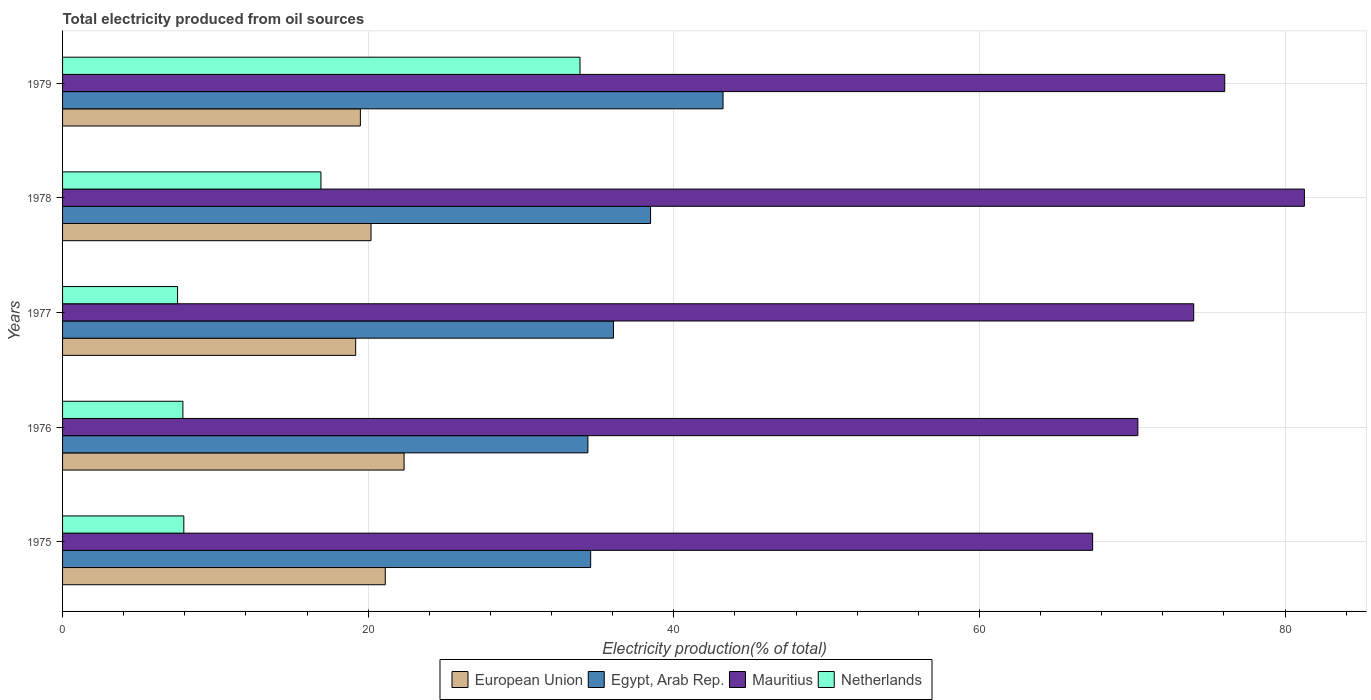How many different coloured bars are there?
Your answer should be compact. 4. How many groups of bars are there?
Keep it short and to the point. 5. Are the number of bars per tick equal to the number of legend labels?
Make the answer very short. Yes. Are the number of bars on each tick of the Y-axis equal?
Provide a succinct answer. Yes. How many bars are there on the 3rd tick from the top?
Offer a terse response. 4. How many bars are there on the 2nd tick from the bottom?
Provide a short and direct response. 4. What is the label of the 4th group of bars from the top?
Make the answer very short. 1976. In how many cases, is the number of bars for a given year not equal to the number of legend labels?
Offer a terse response. 0. What is the total electricity produced in European Union in 1976?
Ensure brevity in your answer.  22.35. Across all years, what is the maximum total electricity produced in European Union?
Provide a succinct answer. 22.35. Across all years, what is the minimum total electricity produced in European Union?
Offer a very short reply. 19.18. In which year was the total electricity produced in Netherlands maximum?
Provide a short and direct response. 1979. In which year was the total electricity produced in Egypt, Arab Rep. minimum?
Make the answer very short. 1976. What is the total total electricity produced in Egypt, Arab Rep. in the graph?
Your answer should be very brief. 186.7. What is the difference between the total electricity produced in Mauritius in 1977 and that in 1979?
Your answer should be very brief. -2.03. What is the difference between the total electricity produced in Netherlands in 1979 and the total electricity produced in European Union in 1978?
Ensure brevity in your answer.  13.68. What is the average total electricity produced in Mauritius per year?
Give a very brief answer. 73.83. In the year 1976, what is the difference between the total electricity produced in Netherlands and total electricity produced in Mauritius?
Offer a very short reply. -62.5. In how many years, is the total electricity produced in Egypt, Arab Rep. greater than 28 %?
Your response must be concise. 5. What is the ratio of the total electricity produced in Netherlands in 1977 to that in 1978?
Give a very brief answer. 0.45. Is the difference between the total electricity produced in Netherlands in 1977 and 1979 greater than the difference between the total electricity produced in Mauritius in 1977 and 1979?
Your answer should be very brief. No. What is the difference between the highest and the second highest total electricity produced in European Union?
Your answer should be very brief. 1.23. What is the difference between the highest and the lowest total electricity produced in European Union?
Keep it short and to the point. 3.17. In how many years, is the total electricity produced in Egypt, Arab Rep. greater than the average total electricity produced in Egypt, Arab Rep. taken over all years?
Offer a very short reply. 2. Is the sum of the total electricity produced in Egypt, Arab Rep. in 1976 and 1977 greater than the maximum total electricity produced in Netherlands across all years?
Make the answer very short. Yes. What does the 4th bar from the top in 1976 represents?
Provide a short and direct response. European Union. What does the 1st bar from the bottom in 1979 represents?
Your answer should be very brief. European Union. How many bars are there?
Make the answer very short. 20. How many years are there in the graph?
Ensure brevity in your answer.  5. Does the graph contain any zero values?
Give a very brief answer. No. Does the graph contain grids?
Offer a terse response. Yes. What is the title of the graph?
Keep it short and to the point. Total electricity produced from oil sources. What is the label or title of the X-axis?
Provide a short and direct response. Electricity production(% of total). What is the Electricity production(% of total) in European Union in 1975?
Offer a very short reply. 21.12. What is the Electricity production(% of total) in Egypt, Arab Rep. in 1975?
Your answer should be compact. 34.56. What is the Electricity production(% of total) in Mauritius in 1975?
Keep it short and to the point. 67.41. What is the Electricity production(% of total) of Netherlands in 1975?
Your answer should be very brief. 7.94. What is the Electricity production(% of total) of European Union in 1976?
Your answer should be compact. 22.35. What is the Electricity production(% of total) in Egypt, Arab Rep. in 1976?
Make the answer very short. 34.38. What is the Electricity production(% of total) in Mauritius in 1976?
Give a very brief answer. 70.37. What is the Electricity production(% of total) in Netherlands in 1976?
Offer a very short reply. 7.87. What is the Electricity production(% of total) of European Union in 1977?
Provide a succinct answer. 19.18. What is the Electricity production(% of total) in Egypt, Arab Rep. in 1977?
Make the answer very short. 36.05. What is the Electricity production(% of total) of Mauritius in 1977?
Ensure brevity in your answer.  74.03. What is the Electricity production(% of total) in Netherlands in 1977?
Your answer should be compact. 7.53. What is the Electricity production(% of total) of European Union in 1978?
Offer a very short reply. 20.19. What is the Electricity production(% of total) in Egypt, Arab Rep. in 1978?
Keep it short and to the point. 38.48. What is the Electricity production(% of total) in Mauritius in 1978?
Offer a terse response. 81.27. What is the Electricity production(% of total) of Netherlands in 1978?
Offer a very short reply. 16.91. What is the Electricity production(% of total) in European Union in 1979?
Offer a terse response. 19.49. What is the Electricity production(% of total) of Egypt, Arab Rep. in 1979?
Offer a very short reply. 43.22. What is the Electricity production(% of total) in Mauritius in 1979?
Make the answer very short. 76.06. What is the Electricity production(% of total) of Netherlands in 1979?
Give a very brief answer. 33.86. Across all years, what is the maximum Electricity production(% of total) of European Union?
Give a very brief answer. 22.35. Across all years, what is the maximum Electricity production(% of total) of Egypt, Arab Rep.?
Offer a very short reply. 43.22. Across all years, what is the maximum Electricity production(% of total) in Mauritius?
Offer a very short reply. 81.27. Across all years, what is the maximum Electricity production(% of total) in Netherlands?
Offer a very short reply. 33.86. Across all years, what is the minimum Electricity production(% of total) in European Union?
Offer a terse response. 19.18. Across all years, what is the minimum Electricity production(% of total) of Egypt, Arab Rep.?
Provide a short and direct response. 34.38. Across all years, what is the minimum Electricity production(% of total) in Mauritius?
Ensure brevity in your answer.  67.41. Across all years, what is the minimum Electricity production(% of total) of Netherlands?
Make the answer very short. 7.53. What is the total Electricity production(% of total) in European Union in the graph?
Keep it short and to the point. 102.33. What is the total Electricity production(% of total) in Egypt, Arab Rep. in the graph?
Offer a terse response. 186.7. What is the total Electricity production(% of total) in Mauritius in the graph?
Make the answer very short. 369.13. What is the total Electricity production(% of total) in Netherlands in the graph?
Make the answer very short. 74.11. What is the difference between the Electricity production(% of total) of European Union in 1975 and that in 1976?
Offer a terse response. -1.23. What is the difference between the Electricity production(% of total) of Egypt, Arab Rep. in 1975 and that in 1976?
Your answer should be very brief. 0.18. What is the difference between the Electricity production(% of total) of Mauritius in 1975 and that in 1976?
Your response must be concise. -2.96. What is the difference between the Electricity production(% of total) of Netherlands in 1975 and that in 1976?
Ensure brevity in your answer.  0.06. What is the difference between the Electricity production(% of total) in European Union in 1975 and that in 1977?
Provide a succinct answer. 1.94. What is the difference between the Electricity production(% of total) of Egypt, Arab Rep. in 1975 and that in 1977?
Your answer should be compact. -1.49. What is the difference between the Electricity production(% of total) in Mauritius in 1975 and that in 1977?
Give a very brief answer. -6.62. What is the difference between the Electricity production(% of total) of Netherlands in 1975 and that in 1977?
Your answer should be very brief. 0.41. What is the difference between the Electricity production(% of total) of European Union in 1975 and that in 1978?
Make the answer very short. 0.93. What is the difference between the Electricity production(% of total) of Egypt, Arab Rep. in 1975 and that in 1978?
Ensure brevity in your answer.  -3.92. What is the difference between the Electricity production(% of total) of Mauritius in 1975 and that in 1978?
Ensure brevity in your answer.  -13.86. What is the difference between the Electricity production(% of total) of Netherlands in 1975 and that in 1978?
Offer a very short reply. -8.97. What is the difference between the Electricity production(% of total) in European Union in 1975 and that in 1979?
Offer a very short reply. 1.63. What is the difference between the Electricity production(% of total) of Egypt, Arab Rep. in 1975 and that in 1979?
Provide a short and direct response. -8.66. What is the difference between the Electricity production(% of total) in Mauritius in 1975 and that in 1979?
Provide a short and direct response. -8.65. What is the difference between the Electricity production(% of total) in Netherlands in 1975 and that in 1979?
Provide a succinct answer. -25.93. What is the difference between the Electricity production(% of total) in European Union in 1976 and that in 1977?
Your response must be concise. 3.17. What is the difference between the Electricity production(% of total) of Egypt, Arab Rep. in 1976 and that in 1977?
Give a very brief answer. -1.67. What is the difference between the Electricity production(% of total) in Mauritius in 1976 and that in 1977?
Give a very brief answer. -3.66. What is the difference between the Electricity production(% of total) of Netherlands in 1976 and that in 1977?
Your answer should be very brief. 0.35. What is the difference between the Electricity production(% of total) in European Union in 1976 and that in 1978?
Your answer should be compact. 2.16. What is the difference between the Electricity production(% of total) of Egypt, Arab Rep. in 1976 and that in 1978?
Your answer should be compact. -4.1. What is the difference between the Electricity production(% of total) in Mauritius in 1976 and that in 1978?
Give a very brief answer. -10.9. What is the difference between the Electricity production(% of total) of Netherlands in 1976 and that in 1978?
Your answer should be compact. -9.03. What is the difference between the Electricity production(% of total) of European Union in 1976 and that in 1979?
Your response must be concise. 2.86. What is the difference between the Electricity production(% of total) in Egypt, Arab Rep. in 1976 and that in 1979?
Your answer should be compact. -8.84. What is the difference between the Electricity production(% of total) of Mauritius in 1976 and that in 1979?
Your response must be concise. -5.69. What is the difference between the Electricity production(% of total) in Netherlands in 1976 and that in 1979?
Your answer should be compact. -25.99. What is the difference between the Electricity production(% of total) of European Union in 1977 and that in 1978?
Offer a very short reply. -1.01. What is the difference between the Electricity production(% of total) in Egypt, Arab Rep. in 1977 and that in 1978?
Keep it short and to the point. -2.43. What is the difference between the Electricity production(% of total) in Mauritius in 1977 and that in 1978?
Offer a very short reply. -7.24. What is the difference between the Electricity production(% of total) in Netherlands in 1977 and that in 1978?
Your response must be concise. -9.38. What is the difference between the Electricity production(% of total) in European Union in 1977 and that in 1979?
Offer a terse response. -0.31. What is the difference between the Electricity production(% of total) in Egypt, Arab Rep. in 1977 and that in 1979?
Offer a very short reply. -7.17. What is the difference between the Electricity production(% of total) of Mauritius in 1977 and that in 1979?
Your answer should be very brief. -2.03. What is the difference between the Electricity production(% of total) of Netherlands in 1977 and that in 1979?
Your answer should be compact. -26.34. What is the difference between the Electricity production(% of total) in European Union in 1978 and that in 1979?
Provide a short and direct response. 0.7. What is the difference between the Electricity production(% of total) in Egypt, Arab Rep. in 1978 and that in 1979?
Offer a terse response. -4.74. What is the difference between the Electricity production(% of total) of Mauritius in 1978 and that in 1979?
Provide a short and direct response. 5.21. What is the difference between the Electricity production(% of total) in Netherlands in 1978 and that in 1979?
Offer a terse response. -16.95. What is the difference between the Electricity production(% of total) of European Union in 1975 and the Electricity production(% of total) of Egypt, Arab Rep. in 1976?
Your answer should be very brief. -13.26. What is the difference between the Electricity production(% of total) in European Union in 1975 and the Electricity production(% of total) in Mauritius in 1976?
Your answer should be compact. -49.25. What is the difference between the Electricity production(% of total) in European Union in 1975 and the Electricity production(% of total) in Netherlands in 1976?
Offer a very short reply. 13.24. What is the difference between the Electricity production(% of total) in Egypt, Arab Rep. in 1975 and the Electricity production(% of total) in Mauritius in 1976?
Provide a succinct answer. -35.81. What is the difference between the Electricity production(% of total) in Egypt, Arab Rep. in 1975 and the Electricity production(% of total) in Netherlands in 1976?
Give a very brief answer. 26.69. What is the difference between the Electricity production(% of total) of Mauritius in 1975 and the Electricity production(% of total) of Netherlands in 1976?
Ensure brevity in your answer.  59.54. What is the difference between the Electricity production(% of total) in European Union in 1975 and the Electricity production(% of total) in Egypt, Arab Rep. in 1977?
Ensure brevity in your answer.  -14.93. What is the difference between the Electricity production(% of total) in European Union in 1975 and the Electricity production(% of total) in Mauritius in 1977?
Your response must be concise. -52.91. What is the difference between the Electricity production(% of total) of European Union in 1975 and the Electricity production(% of total) of Netherlands in 1977?
Provide a short and direct response. 13.59. What is the difference between the Electricity production(% of total) in Egypt, Arab Rep. in 1975 and the Electricity production(% of total) in Mauritius in 1977?
Your answer should be compact. -39.47. What is the difference between the Electricity production(% of total) of Egypt, Arab Rep. in 1975 and the Electricity production(% of total) of Netherlands in 1977?
Offer a terse response. 27.03. What is the difference between the Electricity production(% of total) in Mauritius in 1975 and the Electricity production(% of total) in Netherlands in 1977?
Your answer should be compact. 59.88. What is the difference between the Electricity production(% of total) of European Union in 1975 and the Electricity production(% of total) of Egypt, Arab Rep. in 1978?
Offer a terse response. -17.36. What is the difference between the Electricity production(% of total) of European Union in 1975 and the Electricity production(% of total) of Mauritius in 1978?
Your response must be concise. -60.15. What is the difference between the Electricity production(% of total) of European Union in 1975 and the Electricity production(% of total) of Netherlands in 1978?
Your answer should be very brief. 4.21. What is the difference between the Electricity production(% of total) of Egypt, Arab Rep. in 1975 and the Electricity production(% of total) of Mauritius in 1978?
Provide a short and direct response. -46.71. What is the difference between the Electricity production(% of total) of Egypt, Arab Rep. in 1975 and the Electricity production(% of total) of Netherlands in 1978?
Offer a very short reply. 17.65. What is the difference between the Electricity production(% of total) in Mauritius in 1975 and the Electricity production(% of total) in Netherlands in 1978?
Your response must be concise. 50.5. What is the difference between the Electricity production(% of total) in European Union in 1975 and the Electricity production(% of total) in Egypt, Arab Rep. in 1979?
Give a very brief answer. -22.11. What is the difference between the Electricity production(% of total) in European Union in 1975 and the Electricity production(% of total) in Mauritius in 1979?
Your response must be concise. -54.94. What is the difference between the Electricity production(% of total) in European Union in 1975 and the Electricity production(% of total) in Netherlands in 1979?
Make the answer very short. -12.74. What is the difference between the Electricity production(% of total) of Egypt, Arab Rep. in 1975 and the Electricity production(% of total) of Mauritius in 1979?
Make the answer very short. -41.5. What is the difference between the Electricity production(% of total) of Egypt, Arab Rep. in 1975 and the Electricity production(% of total) of Netherlands in 1979?
Offer a very short reply. 0.7. What is the difference between the Electricity production(% of total) in Mauritius in 1975 and the Electricity production(% of total) in Netherlands in 1979?
Your answer should be very brief. 33.55. What is the difference between the Electricity production(% of total) in European Union in 1976 and the Electricity production(% of total) in Egypt, Arab Rep. in 1977?
Provide a short and direct response. -13.7. What is the difference between the Electricity production(% of total) in European Union in 1976 and the Electricity production(% of total) in Mauritius in 1977?
Provide a succinct answer. -51.68. What is the difference between the Electricity production(% of total) in European Union in 1976 and the Electricity production(% of total) in Netherlands in 1977?
Offer a very short reply. 14.82. What is the difference between the Electricity production(% of total) of Egypt, Arab Rep. in 1976 and the Electricity production(% of total) of Mauritius in 1977?
Your answer should be very brief. -39.65. What is the difference between the Electricity production(% of total) of Egypt, Arab Rep. in 1976 and the Electricity production(% of total) of Netherlands in 1977?
Ensure brevity in your answer.  26.85. What is the difference between the Electricity production(% of total) in Mauritius in 1976 and the Electricity production(% of total) in Netherlands in 1977?
Give a very brief answer. 62.84. What is the difference between the Electricity production(% of total) in European Union in 1976 and the Electricity production(% of total) in Egypt, Arab Rep. in 1978?
Your answer should be compact. -16.13. What is the difference between the Electricity production(% of total) of European Union in 1976 and the Electricity production(% of total) of Mauritius in 1978?
Keep it short and to the point. -58.92. What is the difference between the Electricity production(% of total) in European Union in 1976 and the Electricity production(% of total) in Netherlands in 1978?
Provide a short and direct response. 5.44. What is the difference between the Electricity production(% of total) of Egypt, Arab Rep. in 1976 and the Electricity production(% of total) of Mauritius in 1978?
Provide a succinct answer. -46.89. What is the difference between the Electricity production(% of total) in Egypt, Arab Rep. in 1976 and the Electricity production(% of total) in Netherlands in 1978?
Keep it short and to the point. 17.47. What is the difference between the Electricity production(% of total) of Mauritius in 1976 and the Electricity production(% of total) of Netherlands in 1978?
Make the answer very short. 53.46. What is the difference between the Electricity production(% of total) in European Union in 1976 and the Electricity production(% of total) in Egypt, Arab Rep. in 1979?
Your answer should be very brief. -20.87. What is the difference between the Electricity production(% of total) in European Union in 1976 and the Electricity production(% of total) in Mauritius in 1979?
Provide a short and direct response. -53.71. What is the difference between the Electricity production(% of total) of European Union in 1976 and the Electricity production(% of total) of Netherlands in 1979?
Your response must be concise. -11.51. What is the difference between the Electricity production(% of total) in Egypt, Arab Rep. in 1976 and the Electricity production(% of total) in Mauritius in 1979?
Offer a terse response. -41.68. What is the difference between the Electricity production(% of total) of Egypt, Arab Rep. in 1976 and the Electricity production(% of total) of Netherlands in 1979?
Your answer should be compact. 0.52. What is the difference between the Electricity production(% of total) of Mauritius in 1976 and the Electricity production(% of total) of Netherlands in 1979?
Provide a succinct answer. 36.51. What is the difference between the Electricity production(% of total) in European Union in 1977 and the Electricity production(% of total) in Egypt, Arab Rep. in 1978?
Give a very brief answer. -19.3. What is the difference between the Electricity production(% of total) of European Union in 1977 and the Electricity production(% of total) of Mauritius in 1978?
Offer a terse response. -62.09. What is the difference between the Electricity production(% of total) in European Union in 1977 and the Electricity production(% of total) in Netherlands in 1978?
Offer a terse response. 2.27. What is the difference between the Electricity production(% of total) in Egypt, Arab Rep. in 1977 and the Electricity production(% of total) in Mauritius in 1978?
Ensure brevity in your answer.  -45.22. What is the difference between the Electricity production(% of total) in Egypt, Arab Rep. in 1977 and the Electricity production(% of total) in Netherlands in 1978?
Provide a succinct answer. 19.14. What is the difference between the Electricity production(% of total) in Mauritius in 1977 and the Electricity production(% of total) in Netherlands in 1978?
Your response must be concise. 57.12. What is the difference between the Electricity production(% of total) in European Union in 1977 and the Electricity production(% of total) in Egypt, Arab Rep. in 1979?
Keep it short and to the point. -24.04. What is the difference between the Electricity production(% of total) in European Union in 1977 and the Electricity production(% of total) in Mauritius in 1979?
Keep it short and to the point. -56.87. What is the difference between the Electricity production(% of total) in European Union in 1977 and the Electricity production(% of total) in Netherlands in 1979?
Your answer should be very brief. -14.68. What is the difference between the Electricity production(% of total) in Egypt, Arab Rep. in 1977 and the Electricity production(% of total) in Mauritius in 1979?
Your answer should be very brief. -40. What is the difference between the Electricity production(% of total) in Egypt, Arab Rep. in 1977 and the Electricity production(% of total) in Netherlands in 1979?
Offer a very short reply. 2.19. What is the difference between the Electricity production(% of total) of Mauritius in 1977 and the Electricity production(% of total) of Netherlands in 1979?
Your answer should be compact. 40.16. What is the difference between the Electricity production(% of total) in European Union in 1978 and the Electricity production(% of total) in Egypt, Arab Rep. in 1979?
Your answer should be compact. -23.04. What is the difference between the Electricity production(% of total) of European Union in 1978 and the Electricity production(% of total) of Mauritius in 1979?
Offer a terse response. -55.87. What is the difference between the Electricity production(% of total) in European Union in 1978 and the Electricity production(% of total) in Netherlands in 1979?
Your answer should be compact. -13.68. What is the difference between the Electricity production(% of total) of Egypt, Arab Rep. in 1978 and the Electricity production(% of total) of Mauritius in 1979?
Give a very brief answer. -37.57. What is the difference between the Electricity production(% of total) in Egypt, Arab Rep. in 1978 and the Electricity production(% of total) in Netherlands in 1979?
Your response must be concise. 4.62. What is the difference between the Electricity production(% of total) of Mauritius in 1978 and the Electricity production(% of total) of Netherlands in 1979?
Ensure brevity in your answer.  47.41. What is the average Electricity production(% of total) of European Union per year?
Offer a terse response. 20.47. What is the average Electricity production(% of total) in Egypt, Arab Rep. per year?
Ensure brevity in your answer.  37.34. What is the average Electricity production(% of total) of Mauritius per year?
Your response must be concise. 73.83. What is the average Electricity production(% of total) of Netherlands per year?
Ensure brevity in your answer.  14.82. In the year 1975, what is the difference between the Electricity production(% of total) in European Union and Electricity production(% of total) in Egypt, Arab Rep.?
Give a very brief answer. -13.44. In the year 1975, what is the difference between the Electricity production(% of total) of European Union and Electricity production(% of total) of Mauritius?
Offer a terse response. -46.29. In the year 1975, what is the difference between the Electricity production(% of total) in European Union and Electricity production(% of total) in Netherlands?
Offer a very short reply. 13.18. In the year 1975, what is the difference between the Electricity production(% of total) of Egypt, Arab Rep. and Electricity production(% of total) of Mauritius?
Ensure brevity in your answer.  -32.85. In the year 1975, what is the difference between the Electricity production(% of total) in Egypt, Arab Rep. and Electricity production(% of total) in Netherlands?
Your answer should be compact. 26.62. In the year 1975, what is the difference between the Electricity production(% of total) in Mauritius and Electricity production(% of total) in Netherlands?
Keep it short and to the point. 59.47. In the year 1976, what is the difference between the Electricity production(% of total) in European Union and Electricity production(% of total) in Egypt, Arab Rep.?
Your answer should be very brief. -12.03. In the year 1976, what is the difference between the Electricity production(% of total) in European Union and Electricity production(% of total) in Mauritius?
Your answer should be compact. -48.02. In the year 1976, what is the difference between the Electricity production(% of total) of European Union and Electricity production(% of total) of Netherlands?
Your answer should be very brief. 14.48. In the year 1976, what is the difference between the Electricity production(% of total) of Egypt, Arab Rep. and Electricity production(% of total) of Mauritius?
Provide a short and direct response. -35.99. In the year 1976, what is the difference between the Electricity production(% of total) in Egypt, Arab Rep. and Electricity production(% of total) in Netherlands?
Provide a succinct answer. 26.51. In the year 1976, what is the difference between the Electricity production(% of total) in Mauritius and Electricity production(% of total) in Netherlands?
Offer a very short reply. 62.5. In the year 1977, what is the difference between the Electricity production(% of total) in European Union and Electricity production(% of total) in Egypt, Arab Rep.?
Provide a succinct answer. -16.87. In the year 1977, what is the difference between the Electricity production(% of total) of European Union and Electricity production(% of total) of Mauritius?
Your answer should be compact. -54.84. In the year 1977, what is the difference between the Electricity production(% of total) of European Union and Electricity production(% of total) of Netherlands?
Your answer should be very brief. 11.65. In the year 1977, what is the difference between the Electricity production(% of total) of Egypt, Arab Rep. and Electricity production(% of total) of Mauritius?
Your answer should be compact. -37.97. In the year 1977, what is the difference between the Electricity production(% of total) of Egypt, Arab Rep. and Electricity production(% of total) of Netherlands?
Give a very brief answer. 28.53. In the year 1977, what is the difference between the Electricity production(% of total) in Mauritius and Electricity production(% of total) in Netherlands?
Your answer should be compact. 66.5. In the year 1978, what is the difference between the Electricity production(% of total) in European Union and Electricity production(% of total) in Egypt, Arab Rep.?
Offer a terse response. -18.3. In the year 1978, what is the difference between the Electricity production(% of total) of European Union and Electricity production(% of total) of Mauritius?
Ensure brevity in your answer.  -61.08. In the year 1978, what is the difference between the Electricity production(% of total) in European Union and Electricity production(% of total) in Netherlands?
Provide a short and direct response. 3.28. In the year 1978, what is the difference between the Electricity production(% of total) in Egypt, Arab Rep. and Electricity production(% of total) in Mauritius?
Your answer should be very brief. -42.79. In the year 1978, what is the difference between the Electricity production(% of total) of Egypt, Arab Rep. and Electricity production(% of total) of Netherlands?
Ensure brevity in your answer.  21.57. In the year 1978, what is the difference between the Electricity production(% of total) in Mauritius and Electricity production(% of total) in Netherlands?
Offer a very short reply. 64.36. In the year 1979, what is the difference between the Electricity production(% of total) in European Union and Electricity production(% of total) in Egypt, Arab Rep.?
Give a very brief answer. -23.73. In the year 1979, what is the difference between the Electricity production(% of total) in European Union and Electricity production(% of total) in Mauritius?
Your answer should be compact. -56.57. In the year 1979, what is the difference between the Electricity production(% of total) of European Union and Electricity production(% of total) of Netherlands?
Keep it short and to the point. -14.37. In the year 1979, what is the difference between the Electricity production(% of total) of Egypt, Arab Rep. and Electricity production(% of total) of Mauritius?
Offer a terse response. -32.83. In the year 1979, what is the difference between the Electricity production(% of total) in Egypt, Arab Rep. and Electricity production(% of total) in Netherlands?
Give a very brief answer. 9.36. In the year 1979, what is the difference between the Electricity production(% of total) in Mauritius and Electricity production(% of total) in Netherlands?
Offer a very short reply. 42.19. What is the ratio of the Electricity production(% of total) of European Union in 1975 to that in 1976?
Give a very brief answer. 0.94. What is the ratio of the Electricity production(% of total) in Mauritius in 1975 to that in 1976?
Offer a very short reply. 0.96. What is the ratio of the Electricity production(% of total) of Netherlands in 1975 to that in 1976?
Ensure brevity in your answer.  1.01. What is the ratio of the Electricity production(% of total) in European Union in 1975 to that in 1977?
Provide a short and direct response. 1.1. What is the ratio of the Electricity production(% of total) in Egypt, Arab Rep. in 1975 to that in 1977?
Keep it short and to the point. 0.96. What is the ratio of the Electricity production(% of total) of Mauritius in 1975 to that in 1977?
Offer a very short reply. 0.91. What is the ratio of the Electricity production(% of total) of Netherlands in 1975 to that in 1977?
Provide a succinct answer. 1.05. What is the ratio of the Electricity production(% of total) of European Union in 1975 to that in 1978?
Ensure brevity in your answer.  1.05. What is the ratio of the Electricity production(% of total) in Egypt, Arab Rep. in 1975 to that in 1978?
Give a very brief answer. 0.9. What is the ratio of the Electricity production(% of total) in Mauritius in 1975 to that in 1978?
Make the answer very short. 0.83. What is the ratio of the Electricity production(% of total) in Netherlands in 1975 to that in 1978?
Keep it short and to the point. 0.47. What is the ratio of the Electricity production(% of total) in European Union in 1975 to that in 1979?
Give a very brief answer. 1.08. What is the ratio of the Electricity production(% of total) of Egypt, Arab Rep. in 1975 to that in 1979?
Keep it short and to the point. 0.8. What is the ratio of the Electricity production(% of total) in Mauritius in 1975 to that in 1979?
Your answer should be very brief. 0.89. What is the ratio of the Electricity production(% of total) in Netherlands in 1975 to that in 1979?
Make the answer very short. 0.23. What is the ratio of the Electricity production(% of total) of European Union in 1976 to that in 1977?
Provide a succinct answer. 1.17. What is the ratio of the Electricity production(% of total) of Egypt, Arab Rep. in 1976 to that in 1977?
Provide a short and direct response. 0.95. What is the ratio of the Electricity production(% of total) in Mauritius in 1976 to that in 1977?
Your answer should be very brief. 0.95. What is the ratio of the Electricity production(% of total) in Netherlands in 1976 to that in 1977?
Give a very brief answer. 1.05. What is the ratio of the Electricity production(% of total) in European Union in 1976 to that in 1978?
Offer a very short reply. 1.11. What is the ratio of the Electricity production(% of total) in Egypt, Arab Rep. in 1976 to that in 1978?
Give a very brief answer. 0.89. What is the ratio of the Electricity production(% of total) in Mauritius in 1976 to that in 1978?
Ensure brevity in your answer.  0.87. What is the ratio of the Electricity production(% of total) of Netherlands in 1976 to that in 1978?
Ensure brevity in your answer.  0.47. What is the ratio of the Electricity production(% of total) of European Union in 1976 to that in 1979?
Keep it short and to the point. 1.15. What is the ratio of the Electricity production(% of total) of Egypt, Arab Rep. in 1976 to that in 1979?
Your answer should be compact. 0.8. What is the ratio of the Electricity production(% of total) in Mauritius in 1976 to that in 1979?
Your answer should be very brief. 0.93. What is the ratio of the Electricity production(% of total) of Netherlands in 1976 to that in 1979?
Make the answer very short. 0.23. What is the ratio of the Electricity production(% of total) of European Union in 1977 to that in 1978?
Make the answer very short. 0.95. What is the ratio of the Electricity production(% of total) of Egypt, Arab Rep. in 1977 to that in 1978?
Provide a short and direct response. 0.94. What is the ratio of the Electricity production(% of total) of Mauritius in 1977 to that in 1978?
Offer a terse response. 0.91. What is the ratio of the Electricity production(% of total) in Netherlands in 1977 to that in 1978?
Provide a succinct answer. 0.45. What is the ratio of the Electricity production(% of total) of European Union in 1977 to that in 1979?
Offer a very short reply. 0.98. What is the ratio of the Electricity production(% of total) of Egypt, Arab Rep. in 1977 to that in 1979?
Give a very brief answer. 0.83. What is the ratio of the Electricity production(% of total) of Mauritius in 1977 to that in 1979?
Offer a very short reply. 0.97. What is the ratio of the Electricity production(% of total) of Netherlands in 1977 to that in 1979?
Keep it short and to the point. 0.22. What is the ratio of the Electricity production(% of total) of European Union in 1978 to that in 1979?
Offer a very short reply. 1.04. What is the ratio of the Electricity production(% of total) in Egypt, Arab Rep. in 1978 to that in 1979?
Your answer should be very brief. 0.89. What is the ratio of the Electricity production(% of total) of Mauritius in 1978 to that in 1979?
Make the answer very short. 1.07. What is the ratio of the Electricity production(% of total) of Netherlands in 1978 to that in 1979?
Ensure brevity in your answer.  0.5. What is the difference between the highest and the second highest Electricity production(% of total) in European Union?
Provide a succinct answer. 1.23. What is the difference between the highest and the second highest Electricity production(% of total) in Egypt, Arab Rep.?
Ensure brevity in your answer.  4.74. What is the difference between the highest and the second highest Electricity production(% of total) of Mauritius?
Your answer should be compact. 5.21. What is the difference between the highest and the second highest Electricity production(% of total) of Netherlands?
Offer a terse response. 16.95. What is the difference between the highest and the lowest Electricity production(% of total) of European Union?
Your response must be concise. 3.17. What is the difference between the highest and the lowest Electricity production(% of total) in Egypt, Arab Rep.?
Your response must be concise. 8.84. What is the difference between the highest and the lowest Electricity production(% of total) of Mauritius?
Offer a very short reply. 13.86. What is the difference between the highest and the lowest Electricity production(% of total) of Netherlands?
Offer a terse response. 26.34. 